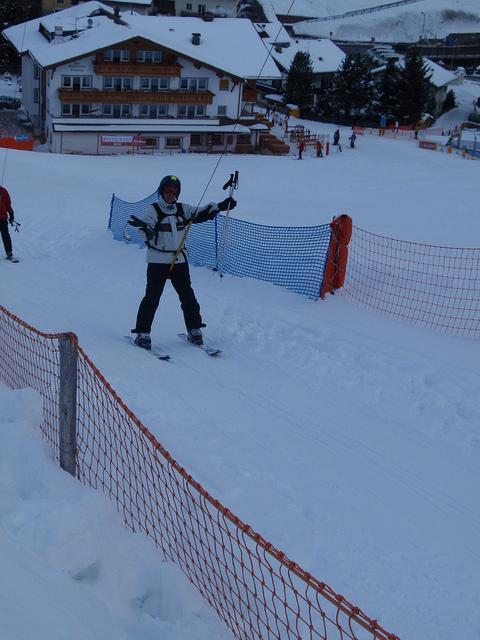How many surfboards are there?
Give a very brief answer. 0. 